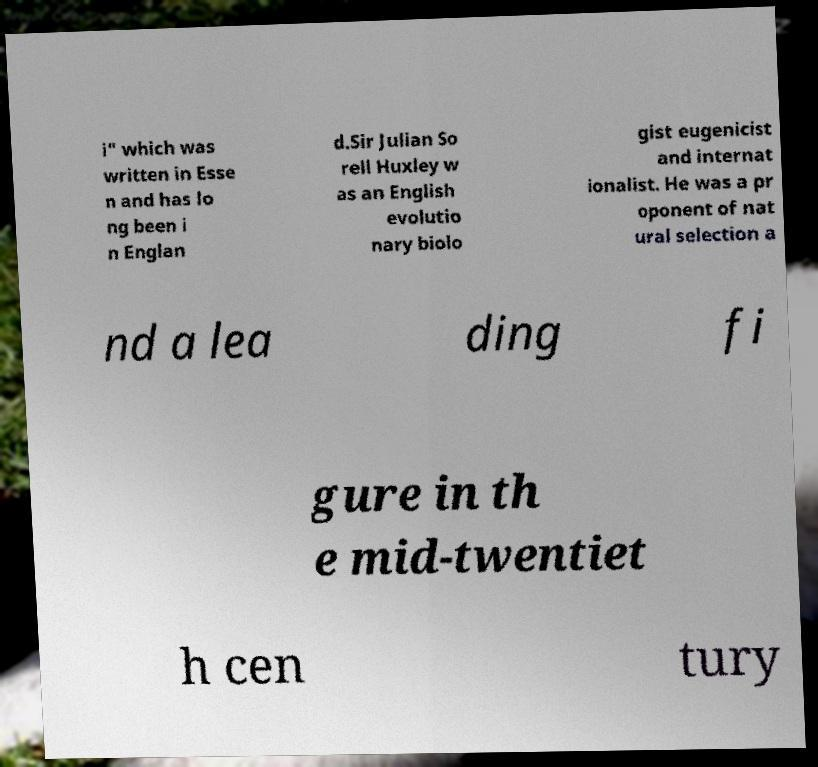Can you accurately transcribe the text from the provided image for me? i" which was written in Esse n and has lo ng been i n Englan d.Sir Julian So rell Huxley w as an English evolutio nary biolo gist eugenicist and internat ionalist. He was a pr oponent of nat ural selection a nd a lea ding fi gure in th e mid-twentiet h cen tury 